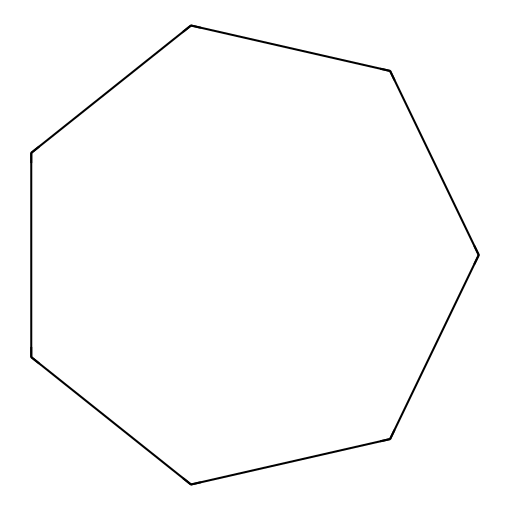What is the name of this chemical? The SMILES representation C1CCCCCC1 corresponds to a cyclic compound with seven carbon atoms. This structure is classified as a cycloalkane, and specifically is named cycloheptane due to its seven-membered carbon ring.
Answer: cycloheptane How many carbon atoms are in cycloheptane? The SMILES notation indicates that there are 7 carbon atoms in total (C1 to C7). The numbering shows a continuous chain that returns to the start, confirming the ring structure.
Answer: 7 What type of hydrocarbon is cycloheptane? Cycloheptane consists only of carbon and hydrogen atoms arranged in a cycle, classifying it as a saturated hydrocarbon and more specifically a cycloalkane. Sat C-H bonds indicate no double or triple bonds present.
Answer: cycloalkane What is the degree of saturation of cycloheptane? Cycloheptane has all single bonds between carbon atoms, leading to a maximum number of hydrogen atoms, resulting in a degree of saturation of zero for this saturated compound (as there are no rings or double bonds).
Answer: zero Describe the molecular geometry of cycloheptane. The molecular geometry of cycloheptane is best described as non-planar (or chair-like) due to the angle strain and hydrogen interactions in a seven-membered ring trying to avoid steric hindrance, making it stable.
Answer: non-planar What is the bond angle in cycloheptane? The bond angles in cycloheptane are approximately 128 degrees due to the arrangement of the carbon atoms in a non-planar ring, which distributes the bond angles evenly as much as possible to reduce strain.
Answer: approximately 128 degrees 